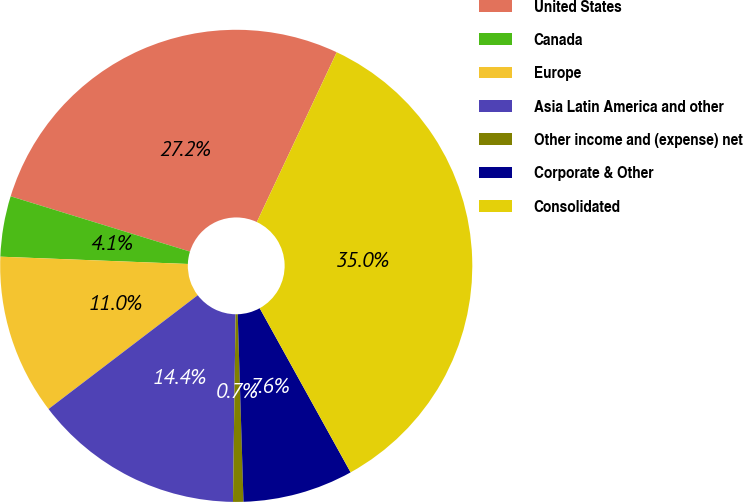<chart> <loc_0><loc_0><loc_500><loc_500><pie_chart><fcel>United States<fcel>Canada<fcel>Europe<fcel>Asia Latin America and other<fcel>Other income and (expense) net<fcel>Corporate & Other<fcel>Consolidated<nl><fcel>27.24%<fcel>4.14%<fcel>10.99%<fcel>14.41%<fcel>0.71%<fcel>7.56%<fcel>34.95%<nl></chart> 